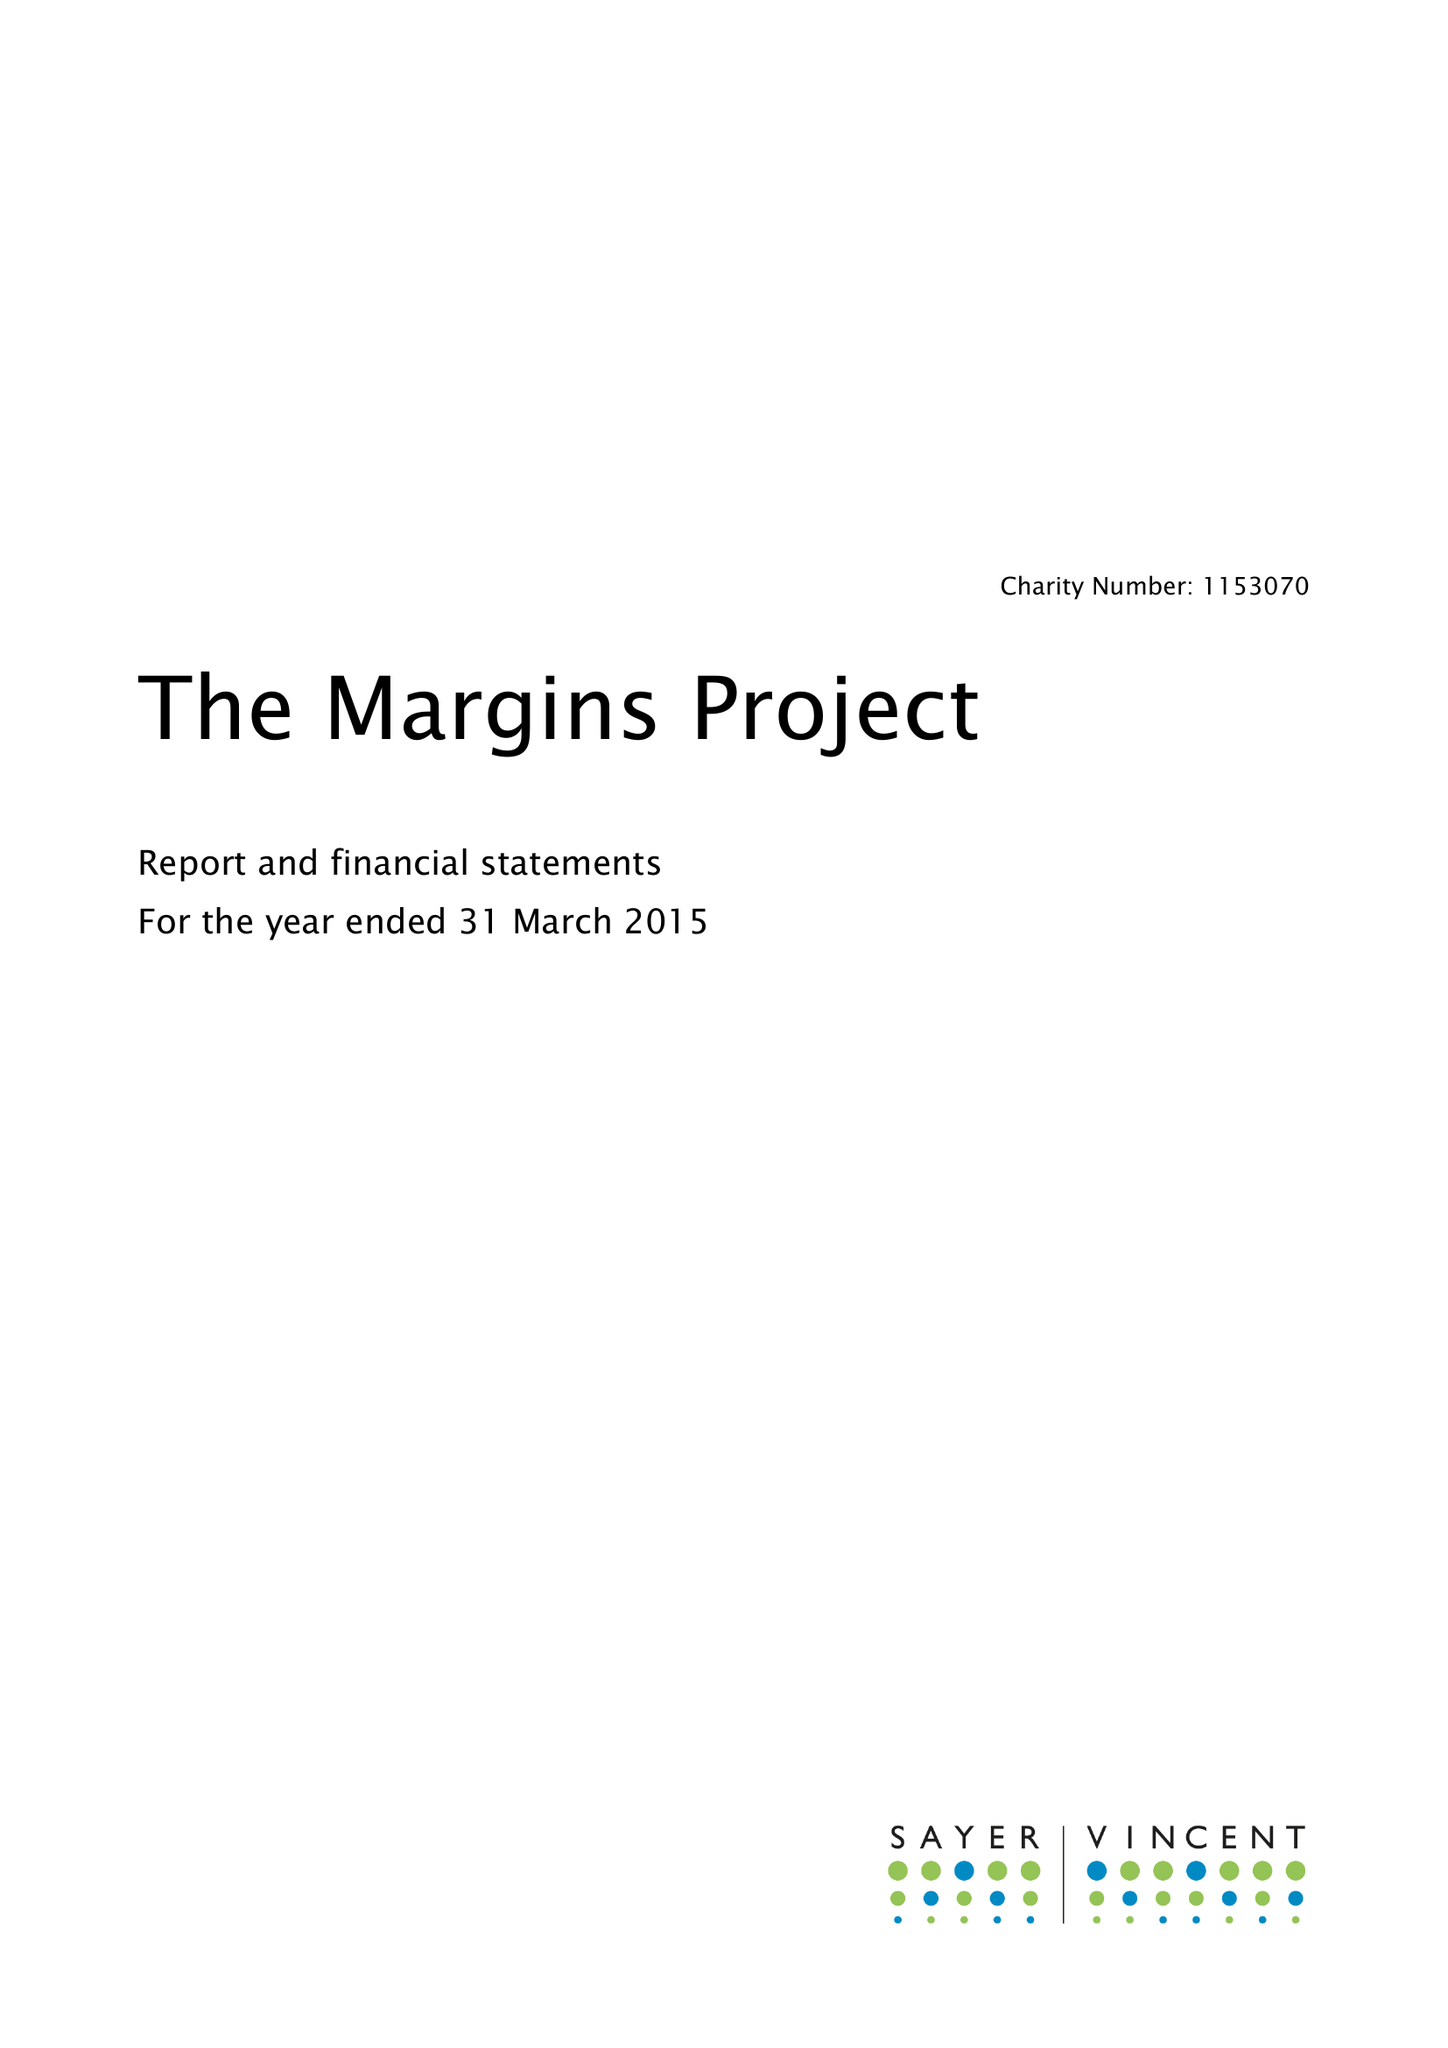What is the value for the charity_number?
Answer the question using a single word or phrase. 1153070 